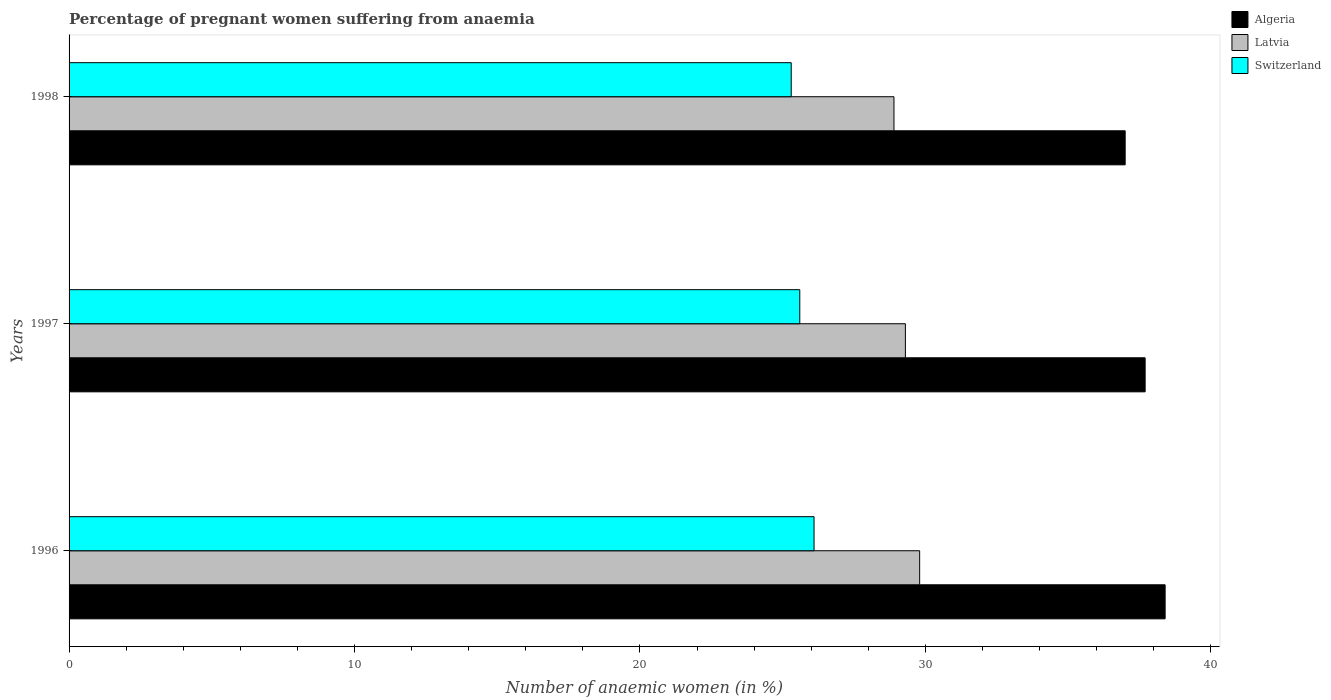How many different coloured bars are there?
Your answer should be compact. 3. How many groups of bars are there?
Keep it short and to the point. 3. Are the number of bars per tick equal to the number of legend labels?
Make the answer very short. Yes. How many bars are there on the 2nd tick from the bottom?
Your answer should be very brief. 3. What is the label of the 2nd group of bars from the top?
Give a very brief answer. 1997. In how many cases, is the number of bars for a given year not equal to the number of legend labels?
Your response must be concise. 0. What is the number of anaemic women in Latvia in 1997?
Offer a very short reply. 29.3. Across all years, what is the maximum number of anaemic women in Latvia?
Make the answer very short. 29.8. Across all years, what is the minimum number of anaemic women in Switzerland?
Offer a very short reply. 25.3. What is the total number of anaemic women in Algeria in the graph?
Provide a short and direct response. 113.1. What is the difference between the number of anaemic women in Algeria in 1996 and that in 1997?
Give a very brief answer. 0.7. What is the difference between the number of anaemic women in Switzerland in 1996 and the number of anaemic women in Latvia in 1998?
Make the answer very short. -2.8. What is the average number of anaemic women in Switzerland per year?
Make the answer very short. 25.67. In the year 1996, what is the difference between the number of anaemic women in Switzerland and number of anaemic women in Latvia?
Offer a terse response. -3.7. What is the ratio of the number of anaemic women in Latvia in 1996 to that in 1998?
Ensure brevity in your answer.  1.03. Is the number of anaemic women in Switzerland in 1996 less than that in 1997?
Provide a succinct answer. No. Is the difference between the number of anaemic women in Switzerland in 1996 and 1998 greater than the difference between the number of anaemic women in Latvia in 1996 and 1998?
Ensure brevity in your answer.  No. What is the difference between the highest and the second highest number of anaemic women in Algeria?
Your answer should be compact. 0.7. What is the difference between the highest and the lowest number of anaemic women in Latvia?
Give a very brief answer. 0.9. Is the sum of the number of anaemic women in Algeria in 1996 and 1998 greater than the maximum number of anaemic women in Switzerland across all years?
Ensure brevity in your answer.  Yes. What does the 1st bar from the top in 1997 represents?
Keep it short and to the point. Switzerland. What does the 1st bar from the bottom in 1996 represents?
Keep it short and to the point. Algeria. What is the difference between two consecutive major ticks on the X-axis?
Offer a very short reply. 10. What is the title of the graph?
Your answer should be compact. Percentage of pregnant women suffering from anaemia. What is the label or title of the X-axis?
Offer a terse response. Number of anaemic women (in %). What is the Number of anaemic women (in %) in Algeria in 1996?
Your answer should be very brief. 38.4. What is the Number of anaemic women (in %) in Latvia in 1996?
Your answer should be very brief. 29.8. What is the Number of anaemic women (in %) in Switzerland in 1996?
Your answer should be very brief. 26.1. What is the Number of anaemic women (in %) of Algeria in 1997?
Offer a terse response. 37.7. What is the Number of anaemic women (in %) of Latvia in 1997?
Offer a terse response. 29.3. What is the Number of anaemic women (in %) of Switzerland in 1997?
Your answer should be compact. 25.6. What is the Number of anaemic women (in %) of Algeria in 1998?
Offer a terse response. 37. What is the Number of anaemic women (in %) in Latvia in 1998?
Your response must be concise. 28.9. What is the Number of anaemic women (in %) in Switzerland in 1998?
Keep it short and to the point. 25.3. Across all years, what is the maximum Number of anaemic women (in %) in Algeria?
Provide a succinct answer. 38.4. Across all years, what is the maximum Number of anaemic women (in %) of Latvia?
Your response must be concise. 29.8. Across all years, what is the maximum Number of anaemic women (in %) of Switzerland?
Make the answer very short. 26.1. Across all years, what is the minimum Number of anaemic women (in %) of Latvia?
Provide a succinct answer. 28.9. Across all years, what is the minimum Number of anaemic women (in %) in Switzerland?
Ensure brevity in your answer.  25.3. What is the total Number of anaemic women (in %) in Algeria in the graph?
Provide a succinct answer. 113.1. What is the difference between the Number of anaemic women (in %) of Algeria in 1996 and that in 1997?
Ensure brevity in your answer.  0.7. What is the difference between the Number of anaemic women (in %) of Algeria in 1996 and that in 1998?
Offer a very short reply. 1.4. What is the difference between the Number of anaemic women (in %) of Algeria in 1997 and that in 1998?
Provide a short and direct response. 0.7. What is the difference between the Number of anaemic women (in %) of Latvia in 1997 and that in 1998?
Keep it short and to the point. 0.4. What is the difference between the Number of anaemic women (in %) of Switzerland in 1997 and that in 1998?
Your answer should be compact. 0.3. What is the difference between the Number of anaemic women (in %) of Algeria in 1996 and the Number of anaemic women (in %) of Switzerland in 1997?
Keep it short and to the point. 12.8. What is the difference between the Number of anaemic women (in %) of Latvia in 1996 and the Number of anaemic women (in %) of Switzerland in 1997?
Make the answer very short. 4.2. What is the difference between the Number of anaemic women (in %) of Algeria in 1996 and the Number of anaemic women (in %) of Latvia in 1998?
Ensure brevity in your answer.  9.5. What is the average Number of anaemic women (in %) of Algeria per year?
Your answer should be compact. 37.7. What is the average Number of anaemic women (in %) of Latvia per year?
Provide a short and direct response. 29.33. What is the average Number of anaemic women (in %) in Switzerland per year?
Your answer should be very brief. 25.67. In the year 1996, what is the difference between the Number of anaemic women (in %) of Algeria and Number of anaemic women (in %) of Latvia?
Your answer should be compact. 8.6. In the year 1997, what is the difference between the Number of anaemic women (in %) in Algeria and Number of anaemic women (in %) in Latvia?
Your response must be concise. 8.4. In the year 1997, what is the difference between the Number of anaemic women (in %) of Latvia and Number of anaemic women (in %) of Switzerland?
Make the answer very short. 3.7. In the year 1998, what is the difference between the Number of anaemic women (in %) in Algeria and Number of anaemic women (in %) in Latvia?
Your response must be concise. 8.1. In the year 1998, what is the difference between the Number of anaemic women (in %) of Algeria and Number of anaemic women (in %) of Switzerland?
Your answer should be very brief. 11.7. In the year 1998, what is the difference between the Number of anaemic women (in %) of Latvia and Number of anaemic women (in %) of Switzerland?
Your answer should be compact. 3.6. What is the ratio of the Number of anaemic women (in %) of Algeria in 1996 to that in 1997?
Keep it short and to the point. 1.02. What is the ratio of the Number of anaemic women (in %) of Latvia in 1996 to that in 1997?
Your response must be concise. 1.02. What is the ratio of the Number of anaemic women (in %) of Switzerland in 1996 to that in 1997?
Offer a terse response. 1.02. What is the ratio of the Number of anaemic women (in %) of Algeria in 1996 to that in 1998?
Your answer should be very brief. 1.04. What is the ratio of the Number of anaemic women (in %) of Latvia in 1996 to that in 1998?
Make the answer very short. 1.03. What is the ratio of the Number of anaemic women (in %) of Switzerland in 1996 to that in 1998?
Ensure brevity in your answer.  1.03. What is the ratio of the Number of anaemic women (in %) of Algeria in 1997 to that in 1998?
Ensure brevity in your answer.  1.02. What is the ratio of the Number of anaemic women (in %) of Latvia in 1997 to that in 1998?
Offer a terse response. 1.01. What is the ratio of the Number of anaemic women (in %) of Switzerland in 1997 to that in 1998?
Your answer should be compact. 1.01. What is the difference between the highest and the second highest Number of anaemic women (in %) of Algeria?
Keep it short and to the point. 0.7. What is the difference between the highest and the second highest Number of anaemic women (in %) in Latvia?
Make the answer very short. 0.5. What is the difference between the highest and the lowest Number of anaemic women (in %) of Algeria?
Ensure brevity in your answer.  1.4. What is the difference between the highest and the lowest Number of anaemic women (in %) in Switzerland?
Keep it short and to the point. 0.8. 